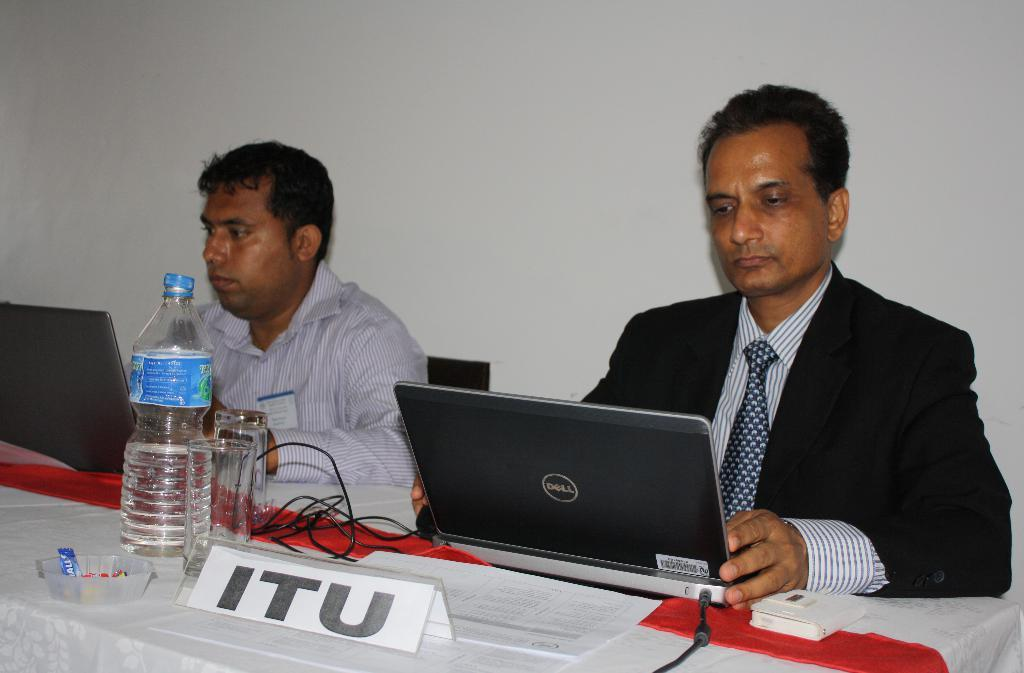<image>
Describe the image concisely. ITU type sign with 2 men that are on laptops sitting at a table. 